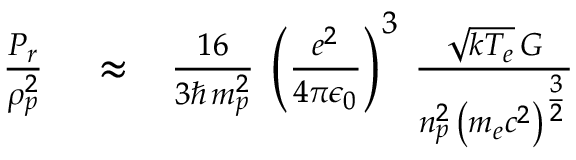<formula> <loc_0><loc_0><loc_500><loc_500>\begin{array} { r l r } { \frac { P _ { r } } { \rho _ { p } ^ { 2 } } } & \approx } & { \frac { 1 6 } { 3 \hbar { \, } m _ { p } ^ { 2 } } \, \left ( \frac { e ^ { 2 } } { 4 \pi \epsilon _ { 0 } } \right ) ^ { 3 } \, \frac { \sqrt { k T _ { e } } \, G } { n _ { p } ^ { 2 } \, \left ( m _ { e } c ^ { 2 } \right ) ^ { \frac { 3 } { 2 } } } } \end{array}</formula> 